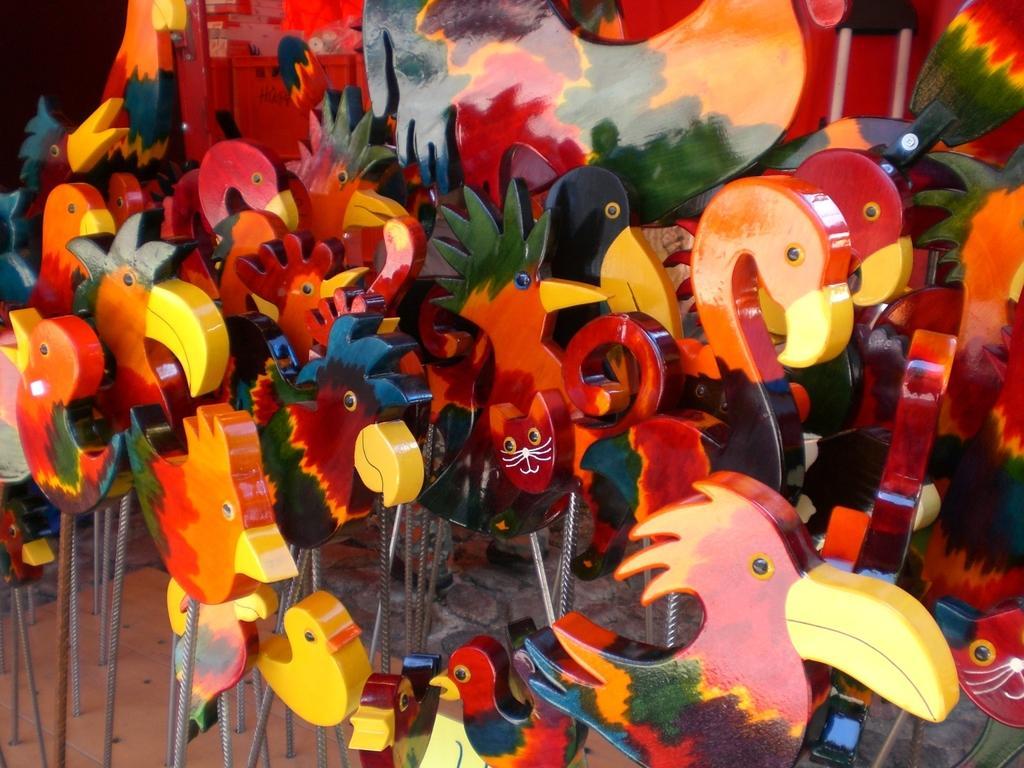Can you describe this image briefly? In this image there are toys and objects. 